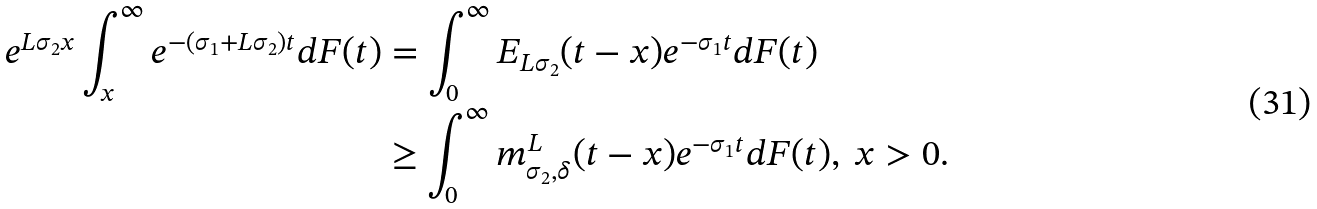<formula> <loc_0><loc_0><loc_500><loc_500>e ^ { L \sigma _ { 2 } x } \int _ { x } ^ { \infty } e ^ { - ( \sigma _ { 1 } + L \sigma _ { 2 } ) t } d F ( t ) & = \int _ { 0 } ^ { \infty } E _ { L \sigma _ { 2 } } ( t - x ) e ^ { - \sigma _ { 1 } t } d F ( t ) \\ & \geq \int _ { 0 } ^ { \infty } m _ { \sigma _ { 2 } , \delta } ^ { L } ( t - x ) e ^ { - \sigma _ { 1 } t } d F ( t ) , \ x > 0 .</formula> 